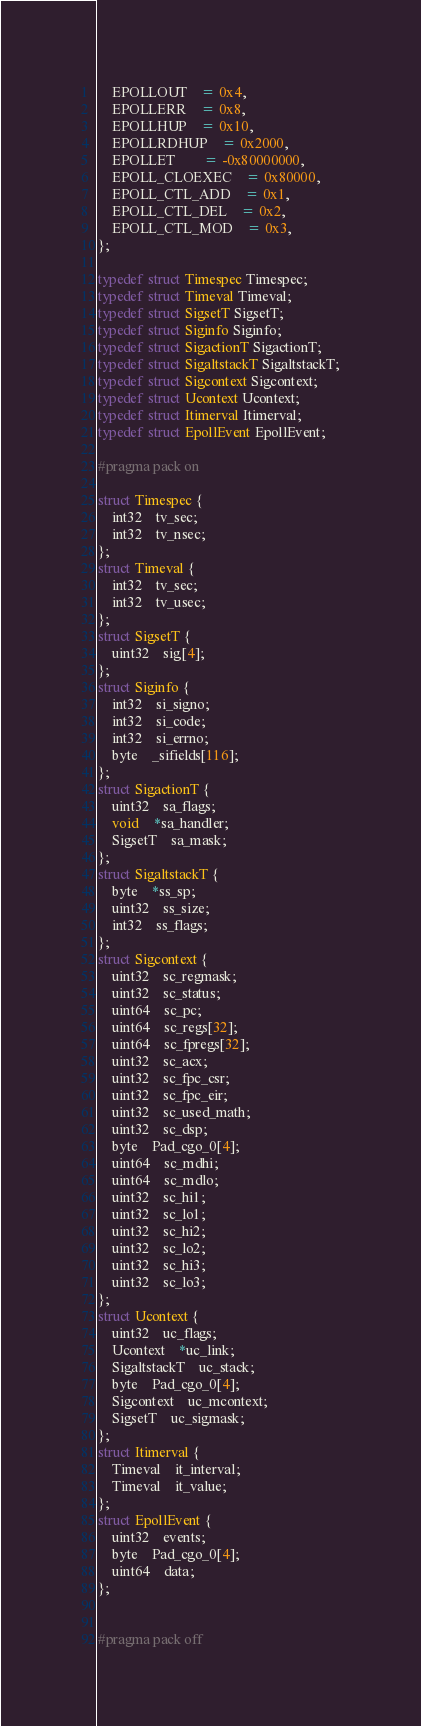<code> <loc_0><loc_0><loc_500><loc_500><_C_>	EPOLLOUT	= 0x4,
	EPOLLERR	= 0x8,
	EPOLLHUP	= 0x10,
	EPOLLRDHUP	= 0x2000,
	EPOLLET		= -0x80000000,
	EPOLL_CLOEXEC	= 0x80000,
	EPOLL_CTL_ADD	= 0x1,
	EPOLL_CTL_DEL	= 0x2,
	EPOLL_CTL_MOD	= 0x3,
};

typedef struct Timespec Timespec;
typedef struct Timeval Timeval;
typedef struct SigsetT SigsetT;
typedef struct Siginfo Siginfo;
typedef struct SigactionT SigactionT;
typedef struct SigaltstackT SigaltstackT;
typedef struct Sigcontext Sigcontext;
typedef struct Ucontext Ucontext;
typedef struct Itimerval Itimerval;
typedef struct EpollEvent EpollEvent;

#pragma pack on

struct Timespec {
	int32	tv_sec;
	int32	tv_nsec;
};
struct Timeval {
	int32	tv_sec;
	int32	tv_usec;
};
struct SigsetT {
	uint32	sig[4];
};
struct Siginfo {
	int32	si_signo;
	int32	si_code;
	int32	si_errno;
	byte	_sifields[116];
};
struct SigactionT {
	uint32	sa_flags;
	void	*sa_handler;
	SigsetT	sa_mask;
};
struct SigaltstackT {
	byte	*ss_sp;
	uint32	ss_size;
	int32	ss_flags;
};
struct Sigcontext {
	uint32	sc_regmask;
	uint32	sc_status;
	uint64	sc_pc;
	uint64	sc_regs[32];
	uint64	sc_fpregs[32];
	uint32	sc_acx;
	uint32	sc_fpc_csr;
	uint32	sc_fpc_eir;
	uint32	sc_used_math;
	uint32	sc_dsp;
	byte	Pad_cgo_0[4];
	uint64	sc_mdhi;
	uint64	sc_mdlo;
	uint32	sc_hi1;
	uint32	sc_lo1;
	uint32	sc_hi2;
	uint32	sc_lo2;
	uint32	sc_hi3;
	uint32	sc_lo3;
};
struct Ucontext {
	uint32	uc_flags;
	Ucontext	*uc_link;
	SigaltstackT	uc_stack;
	byte	Pad_cgo_0[4];
	Sigcontext	uc_mcontext;
	SigsetT	uc_sigmask;
};
struct Itimerval {
	Timeval	it_interval;
	Timeval	it_value;
};
struct EpollEvent {
	uint32	events;
	byte	Pad_cgo_0[4];
	uint64	data;
};


#pragma pack off
</code> 